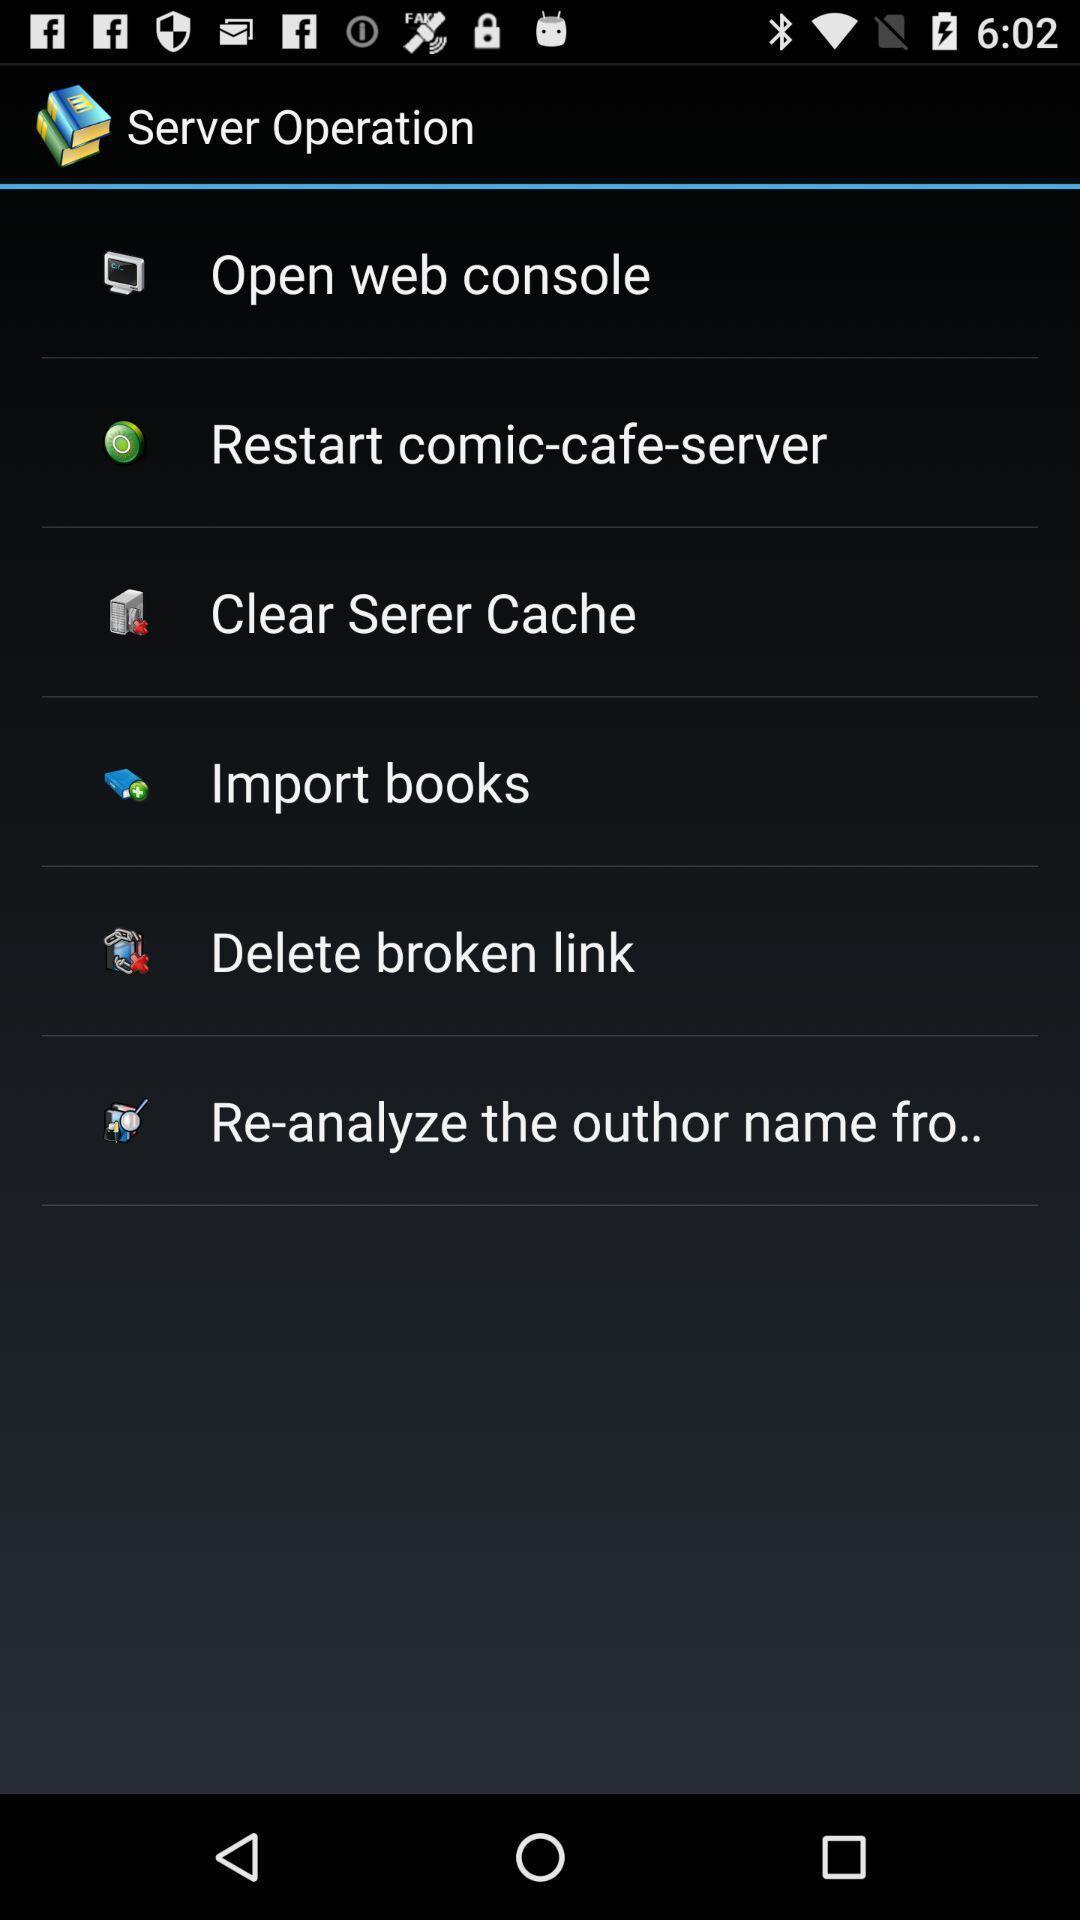Describe the key features of this screenshot. Screen showing server operation options. 